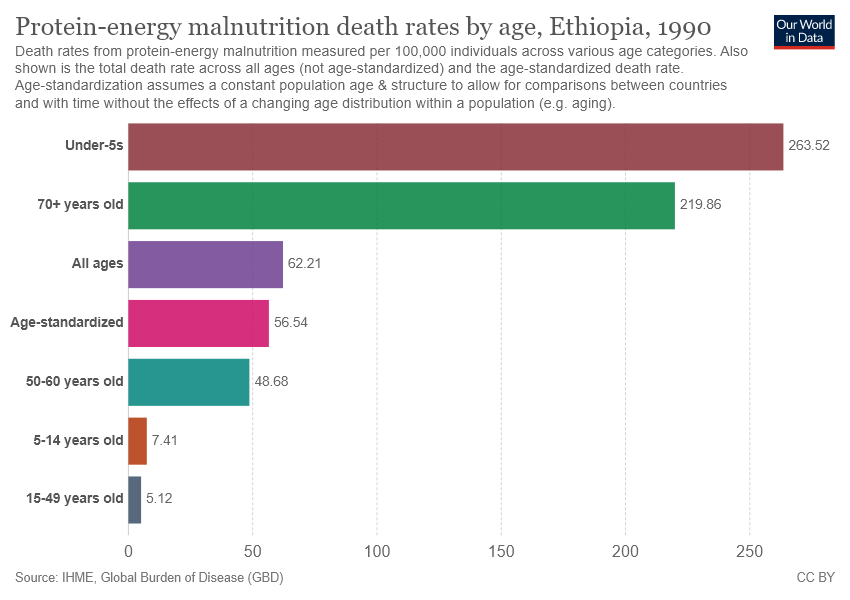Outline some significant characteristics in this image. The bar graph shows seven different age groups. The under-5 age group shows the highest value of death rate due to Ethiopia. 